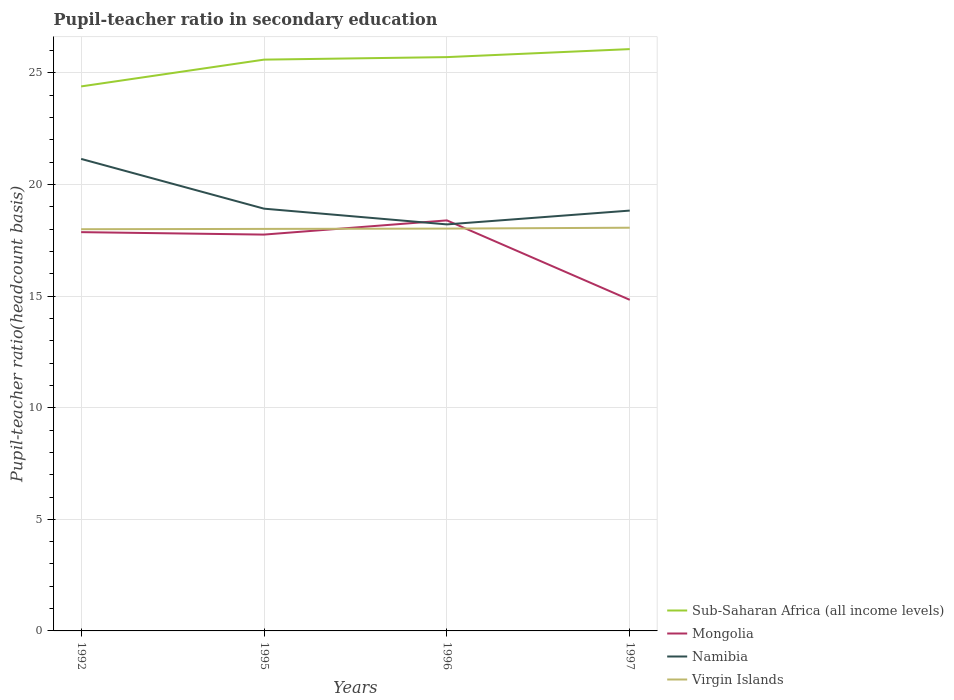How many different coloured lines are there?
Your answer should be very brief. 4. Does the line corresponding to Sub-Saharan Africa (all income levels) intersect with the line corresponding to Namibia?
Offer a very short reply. No. Is the number of lines equal to the number of legend labels?
Give a very brief answer. Yes. Across all years, what is the maximum pupil-teacher ratio in secondary education in Namibia?
Your response must be concise. 18.22. In which year was the pupil-teacher ratio in secondary education in Mongolia maximum?
Offer a very short reply. 1997. What is the total pupil-teacher ratio in secondary education in Sub-Saharan Africa (all income levels) in the graph?
Offer a very short reply. -0.47. What is the difference between the highest and the second highest pupil-teacher ratio in secondary education in Sub-Saharan Africa (all income levels)?
Your answer should be compact. 1.67. How many years are there in the graph?
Give a very brief answer. 4. What is the difference between two consecutive major ticks on the Y-axis?
Provide a short and direct response. 5. Are the values on the major ticks of Y-axis written in scientific E-notation?
Provide a short and direct response. No. Does the graph contain grids?
Ensure brevity in your answer.  Yes. How many legend labels are there?
Offer a very short reply. 4. How are the legend labels stacked?
Your response must be concise. Vertical. What is the title of the graph?
Give a very brief answer. Pupil-teacher ratio in secondary education. Does "Hong Kong" appear as one of the legend labels in the graph?
Keep it short and to the point. No. What is the label or title of the X-axis?
Offer a very short reply. Years. What is the label or title of the Y-axis?
Give a very brief answer. Pupil-teacher ratio(headcount basis). What is the Pupil-teacher ratio(headcount basis) of Sub-Saharan Africa (all income levels) in 1992?
Your response must be concise. 24.4. What is the Pupil-teacher ratio(headcount basis) of Mongolia in 1992?
Make the answer very short. 17.87. What is the Pupil-teacher ratio(headcount basis) in Namibia in 1992?
Provide a short and direct response. 21.15. What is the Pupil-teacher ratio(headcount basis) of Sub-Saharan Africa (all income levels) in 1995?
Provide a succinct answer. 25.6. What is the Pupil-teacher ratio(headcount basis) of Mongolia in 1995?
Offer a terse response. 17.76. What is the Pupil-teacher ratio(headcount basis) in Namibia in 1995?
Keep it short and to the point. 18.92. What is the Pupil-teacher ratio(headcount basis) in Virgin Islands in 1995?
Provide a short and direct response. 18.01. What is the Pupil-teacher ratio(headcount basis) of Sub-Saharan Africa (all income levels) in 1996?
Give a very brief answer. 25.71. What is the Pupil-teacher ratio(headcount basis) in Mongolia in 1996?
Offer a terse response. 18.4. What is the Pupil-teacher ratio(headcount basis) of Namibia in 1996?
Offer a terse response. 18.22. What is the Pupil-teacher ratio(headcount basis) in Virgin Islands in 1996?
Make the answer very short. 18.03. What is the Pupil-teacher ratio(headcount basis) in Sub-Saharan Africa (all income levels) in 1997?
Give a very brief answer. 26.07. What is the Pupil-teacher ratio(headcount basis) of Mongolia in 1997?
Provide a succinct answer. 14.84. What is the Pupil-teacher ratio(headcount basis) of Namibia in 1997?
Your answer should be very brief. 18.83. What is the Pupil-teacher ratio(headcount basis) in Virgin Islands in 1997?
Ensure brevity in your answer.  18.07. Across all years, what is the maximum Pupil-teacher ratio(headcount basis) of Sub-Saharan Africa (all income levels)?
Offer a very short reply. 26.07. Across all years, what is the maximum Pupil-teacher ratio(headcount basis) of Mongolia?
Your answer should be compact. 18.4. Across all years, what is the maximum Pupil-teacher ratio(headcount basis) of Namibia?
Provide a short and direct response. 21.15. Across all years, what is the maximum Pupil-teacher ratio(headcount basis) in Virgin Islands?
Give a very brief answer. 18.07. Across all years, what is the minimum Pupil-teacher ratio(headcount basis) in Sub-Saharan Africa (all income levels)?
Your response must be concise. 24.4. Across all years, what is the minimum Pupil-teacher ratio(headcount basis) in Mongolia?
Provide a succinct answer. 14.84. Across all years, what is the minimum Pupil-teacher ratio(headcount basis) of Namibia?
Your answer should be very brief. 18.22. Across all years, what is the minimum Pupil-teacher ratio(headcount basis) in Virgin Islands?
Your answer should be compact. 18. What is the total Pupil-teacher ratio(headcount basis) of Sub-Saharan Africa (all income levels) in the graph?
Offer a terse response. 101.78. What is the total Pupil-teacher ratio(headcount basis) in Mongolia in the graph?
Provide a short and direct response. 68.86. What is the total Pupil-teacher ratio(headcount basis) of Namibia in the graph?
Your response must be concise. 77.12. What is the total Pupil-teacher ratio(headcount basis) of Virgin Islands in the graph?
Offer a very short reply. 72.11. What is the difference between the Pupil-teacher ratio(headcount basis) of Sub-Saharan Africa (all income levels) in 1992 and that in 1995?
Give a very brief answer. -1.2. What is the difference between the Pupil-teacher ratio(headcount basis) in Mongolia in 1992 and that in 1995?
Provide a succinct answer. 0.11. What is the difference between the Pupil-teacher ratio(headcount basis) in Namibia in 1992 and that in 1995?
Your answer should be very brief. 2.23. What is the difference between the Pupil-teacher ratio(headcount basis) of Virgin Islands in 1992 and that in 1995?
Your answer should be compact. -0.01. What is the difference between the Pupil-teacher ratio(headcount basis) in Sub-Saharan Africa (all income levels) in 1992 and that in 1996?
Make the answer very short. -1.31. What is the difference between the Pupil-teacher ratio(headcount basis) of Mongolia in 1992 and that in 1996?
Provide a succinct answer. -0.53. What is the difference between the Pupil-teacher ratio(headcount basis) of Namibia in 1992 and that in 1996?
Give a very brief answer. 2.93. What is the difference between the Pupil-teacher ratio(headcount basis) of Virgin Islands in 1992 and that in 1996?
Provide a short and direct response. -0.03. What is the difference between the Pupil-teacher ratio(headcount basis) in Sub-Saharan Africa (all income levels) in 1992 and that in 1997?
Provide a short and direct response. -1.67. What is the difference between the Pupil-teacher ratio(headcount basis) of Mongolia in 1992 and that in 1997?
Your response must be concise. 3.03. What is the difference between the Pupil-teacher ratio(headcount basis) in Namibia in 1992 and that in 1997?
Provide a short and direct response. 2.32. What is the difference between the Pupil-teacher ratio(headcount basis) in Virgin Islands in 1992 and that in 1997?
Give a very brief answer. -0.07. What is the difference between the Pupil-teacher ratio(headcount basis) in Sub-Saharan Africa (all income levels) in 1995 and that in 1996?
Provide a short and direct response. -0.11. What is the difference between the Pupil-teacher ratio(headcount basis) of Mongolia in 1995 and that in 1996?
Offer a very short reply. -0.64. What is the difference between the Pupil-teacher ratio(headcount basis) of Namibia in 1995 and that in 1996?
Offer a terse response. 0.71. What is the difference between the Pupil-teacher ratio(headcount basis) of Virgin Islands in 1995 and that in 1996?
Give a very brief answer. -0.01. What is the difference between the Pupil-teacher ratio(headcount basis) in Sub-Saharan Africa (all income levels) in 1995 and that in 1997?
Your answer should be compact. -0.47. What is the difference between the Pupil-teacher ratio(headcount basis) in Mongolia in 1995 and that in 1997?
Offer a very short reply. 2.92. What is the difference between the Pupil-teacher ratio(headcount basis) in Namibia in 1995 and that in 1997?
Keep it short and to the point. 0.09. What is the difference between the Pupil-teacher ratio(headcount basis) in Virgin Islands in 1995 and that in 1997?
Offer a very short reply. -0.05. What is the difference between the Pupil-teacher ratio(headcount basis) in Sub-Saharan Africa (all income levels) in 1996 and that in 1997?
Offer a terse response. -0.36. What is the difference between the Pupil-teacher ratio(headcount basis) of Mongolia in 1996 and that in 1997?
Offer a terse response. 3.56. What is the difference between the Pupil-teacher ratio(headcount basis) in Namibia in 1996 and that in 1997?
Ensure brevity in your answer.  -0.62. What is the difference between the Pupil-teacher ratio(headcount basis) in Virgin Islands in 1996 and that in 1997?
Give a very brief answer. -0.04. What is the difference between the Pupil-teacher ratio(headcount basis) in Sub-Saharan Africa (all income levels) in 1992 and the Pupil-teacher ratio(headcount basis) in Mongolia in 1995?
Provide a short and direct response. 6.64. What is the difference between the Pupil-teacher ratio(headcount basis) of Sub-Saharan Africa (all income levels) in 1992 and the Pupil-teacher ratio(headcount basis) of Namibia in 1995?
Your answer should be compact. 5.48. What is the difference between the Pupil-teacher ratio(headcount basis) in Sub-Saharan Africa (all income levels) in 1992 and the Pupil-teacher ratio(headcount basis) in Virgin Islands in 1995?
Provide a short and direct response. 6.38. What is the difference between the Pupil-teacher ratio(headcount basis) in Mongolia in 1992 and the Pupil-teacher ratio(headcount basis) in Namibia in 1995?
Keep it short and to the point. -1.05. What is the difference between the Pupil-teacher ratio(headcount basis) in Mongolia in 1992 and the Pupil-teacher ratio(headcount basis) in Virgin Islands in 1995?
Your answer should be compact. -0.14. What is the difference between the Pupil-teacher ratio(headcount basis) in Namibia in 1992 and the Pupil-teacher ratio(headcount basis) in Virgin Islands in 1995?
Your answer should be very brief. 3.14. What is the difference between the Pupil-teacher ratio(headcount basis) of Sub-Saharan Africa (all income levels) in 1992 and the Pupil-teacher ratio(headcount basis) of Mongolia in 1996?
Offer a terse response. 6. What is the difference between the Pupil-teacher ratio(headcount basis) in Sub-Saharan Africa (all income levels) in 1992 and the Pupil-teacher ratio(headcount basis) in Namibia in 1996?
Keep it short and to the point. 6.18. What is the difference between the Pupil-teacher ratio(headcount basis) in Sub-Saharan Africa (all income levels) in 1992 and the Pupil-teacher ratio(headcount basis) in Virgin Islands in 1996?
Offer a terse response. 6.37. What is the difference between the Pupil-teacher ratio(headcount basis) of Mongolia in 1992 and the Pupil-teacher ratio(headcount basis) of Namibia in 1996?
Offer a very short reply. -0.35. What is the difference between the Pupil-teacher ratio(headcount basis) of Mongolia in 1992 and the Pupil-teacher ratio(headcount basis) of Virgin Islands in 1996?
Your answer should be very brief. -0.16. What is the difference between the Pupil-teacher ratio(headcount basis) of Namibia in 1992 and the Pupil-teacher ratio(headcount basis) of Virgin Islands in 1996?
Give a very brief answer. 3.12. What is the difference between the Pupil-teacher ratio(headcount basis) of Sub-Saharan Africa (all income levels) in 1992 and the Pupil-teacher ratio(headcount basis) of Mongolia in 1997?
Make the answer very short. 9.56. What is the difference between the Pupil-teacher ratio(headcount basis) of Sub-Saharan Africa (all income levels) in 1992 and the Pupil-teacher ratio(headcount basis) of Namibia in 1997?
Your answer should be compact. 5.56. What is the difference between the Pupil-teacher ratio(headcount basis) in Sub-Saharan Africa (all income levels) in 1992 and the Pupil-teacher ratio(headcount basis) in Virgin Islands in 1997?
Offer a terse response. 6.33. What is the difference between the Pupil-teacher ratio(headcount basis) of Mongolia in 1992 and the Pupil-teacher ratio(headcount basis) of Namibia in 1997?
Offer a very short reply. -0.97. What is the difference between the Pupil-teacher ratio(headcount basis) of Mongolia in 1992 and the Pupil-teacher ratio(headcount basis) of Virgin Islands in 1997?
Ensure brevity in your answer.  -0.2. What is the difference between the Pupil-teacher ratio(headcount basis) in Namibia in 1992 and the Pupil-teacher ratio(headcount basis) in Virgin Islands in 1997?
Ensure brevity in your answer.  3.08. What is the difference between the Pupil-teacher ratio(headcount basis) in Sub-Saharan Africa (all income levels) in 1995 and the Pupil-teacher ratio(headcount basis) in Mongolia in 1996?
Your answer should be very brief. 7.2. What is the difference between the Pupil-teacher ratio(headcount basis) of Sub-Saharan Africa (all income levels) in 1995 and the Pupil-teacher ratio(headcount basis) of Namibia in 1996?
Offer a terse response. 7.38. What is the difference between the Pupil-teacher ratio(headcount basis) in Sub-Saharan Africa (all income levels) in 1995 and the Pupil-teacher ratio(headcount basis) in Virgin Islands in 1996?
Make the answer very short. 7.57. What is the difference between the Pupil-teacher ratio(headcount basis) of Mongolia in 1995 and the Pupil-teacher ratio(headcount basis) of Namibia in 1996?
Give a very brief answer. -0.46. What is the difference between the Pupil-teacher ratio(headcount basis) of Mongolia in 1995 and the Pupil-teacher ratio(headcount basis) of Virgin Islands in 1996?
Give a very brief answer. -0.27. What is the difference between the Pupil-teacher ratio(headcount basis) of Namibia in 1995 and the Pupil-teacher ratio(headcount basis) of Virgin Islands in 1996?
Your answer should be very brief. 0.89. What is the difference between the Pupil-teacher ratio(headcount basis) of Sub-Saharan Africa (all income levels) in 1995 and the Pupil-teacher ratio(headcount basis) of Mongolia in 1997?
Offer a terse response. 10.76. What is the difference between the Pupil-teacher ratio(headcount basis) in Sub-Saharan Africa (all income levels) in 1995 and the Pupil-teacher ratio(headcount basis) in Namibia in 1997?
Provide a short and direct response. 6.76. What is the difference between the Pupil-teacher ratio(headcount basis) of Sub-Saharan Africa (all income levels) in 1995 and the Pupil-teacher ratio(headcount basis) of Virgin Islands in 1997?
Provide a short and direct response. 7.53. What is the difference between the Pupil-teacher ratio(headcount basis) in Mongolia in 1995 and the Pupil-teacher ratio(headcount basis) in Namibia in 1997?
Offer a terse response. -1.08. What is the difference between the Pupil-teacher ratio(headcount basis) in Mongolia in 1995 and the Pupil-teacher ratio(headcount basis) in Virgin Islands in 1997?
Give a very brief answer. -0.31. What is the difference between the Pupil-teacher ratio(headcount basis) in Namibia in 1995 and the Pupil-teacher ratio(headcount basis) in Virgin Islands in 1997?
Offer a terse response. 0.85. What is the difference between the Pupil-teacher ratio(headcount basis) of Sub-Saharan Africa (all income levels) in 1996 and the Pupil-teacher ratio(headcount basis) of Mongolia in 1997?
Your answer should be very brief. 10.88. What is the difference between the Pupil-teacher ratio(headcount basis) in Sub-Saharan Africa (all income levels) in 1996 and the Pupil-teacher ratio(headcount basis) in Namibia in 1997?
Your answer should be compact. 6.88. What is the difference between the Pupil-teacher ratio(headcount basis) of Sub-Saharan Africa (all income levels) in 1996 and the Pupil-teacher ratio(headcount basis) of Virgin Islands in 1997?
Your response must be concise. 7.64. What is the difference between the Pupil-teacher ratio(headcount basis) of Mongolia in 1996 and the Pupil-teacher ratio(headcount basis) of Namibia in 1997?
Make the answer very short. -0.44. What is the difference between the Pupil-teacher ratio(headcount basis) of Mongolia in 1996 and the Pupil-teacher ratio(headcount basis) of Virgin Islands in 1997?
Your response must be concise. 0.33. What is the difference between the Pupil-teacher ratio(headcount basis) of Namibia in 1996 and the Pupil-teacher ratio(headcount basis) of Virgin Islands in 1997?
Give a very brief answer. 0.15. What is the average Pupil-teacher ratio(headcount basis) of Sub-Saharan Africa (all income levels) per year?
Provide a short and direct response. 25.45. What is the average Pupil-teacher ratio(headcount basis) of Mongolia per year?
Offer a terse response. 17.22. What is the average Pupil-teacher ratio(headcount basis) in Namibia per year?
Provide a short and direct response. 19.28. What is the average Pupil-teacher ratio(headcount basis) of Virgin Islands per year?
Make the answer very short. 18.03. In the year 1992, what is the difference between the Pupil-teacher ratio(headcount basis) in Sub-Saharan Africa (all income levels) and Pupil-teacher ratio(headcount basis) in Mongolia?
Keep it short and to the point. 6.53. In the year 1992, what is the difference between the Pupil-teacher ratio(headcount basis) in Sub-Saharan Africa (all income levels) and Pupil-teacher ratio(headcount basis) in Namibia?
Offer a terse response. 3.25. In the year 1992, what is the difference between the Pupil-teacher ratio(headcount basis) of Sub-Saharan Africa (all income levels) and Pupil-teacher ratio(headcount basis) of Virgin Islands?
Your answer should be very brief. 6.4. In the year 1992, what is the difference between the Pupil-teacher ratio(headcount basis) of Mongolia and Pupil-teacher ratio(headcount basis) of Namibia?
Your response must be concise. -3.28. In the year 1992, what is the difference between the Pupil-teacher ratio(headcount basis) in Mongolia and Pupil-teacher ratio(headcount basis) in Virgin Islands?
Your response must be concise. -0.13. In the year 1992, what is the difference between the Pupil-teacher ratio(headcount basis) of Namibia and Pupil-teacher ratio(headcount basis) of Virgin Islands?
Offer a terse response. 3.15. In the year 1995, what is the difference between the Pupil-teacher ratio(headcount basis) of Sub-Saharan Africa (all income levels) and Pupil-teacher ratio(headcount basis) of Mongolia?
Offer a terse response. 7.84. In the year 1995, what is the difference between the Pupil-teacher ratio(headcount basis) in Sub-Saharan Africa (all income levels) and Pupil-teacher ratio(headcount basis) in Namibia?
Offer a terse response. 6.68. In the year 1995, what is the difference between the Pupil-teacher ratio(headcount basis) of Sub-Saharan Africa (all income levels) and Pupil-teacher ratio(headcount basis) of Virgin Islands?
Offer a terse response. 7.58. In the year 1995, what is the difference between the Pupil-teacher ratio(headcount basis) of Mongolia and Pupil-teacher ratio(headcount basis) of Namibia?
Your answer should be very brief. -1.16. In the year 1995, what is the difference between the Pupil-teacher ratio(headcount basis) in Mongolia and Pupil-teacher ratio(headcount basis) in Virgin Islands?
Provide a short and direct response. -0.25. In the year 1995, what is the difference between the Pupil-teacher ratio(headcount basis) of Namibia and Pupil-teacher ratio(headcount basis) of Virgin Islands?
Offer a terse response. 0.91. In the year 1996, what is the difference between the Pupil-teacher ratio(headcount basis) in Sub-Saharan Africa (all income levels) and Pupil-teacher ratio(headcount basis) in Mongolia?
Your response must be concise. 7.32. In the year 1996, what is the difference between the Pupil-teacher ratio(headcount basis) of Sub-Saharan Africa (all income levels) and Pupil-teacher ratio(headcount basis) of Namibia?
Give a very brief answer. 7.5. In the year 1996, what is the difference between the Pupil-teacher ratio(headcount basis) of Sub-Saharan Africa (all income levels) and Pupil-teacher ratio(headcount basis) of Virgin Islands?
Offer a very short reply. 7.68. In the year 1996, what is the difference between the Pupil-teacher ratio(headcount basis) of Mongolia and Pupil-teacher ratio(headcount basis) of Namibia?
Your answer should be very brief. 0.18. In the year 1996, what is the difference between the Pupil-teacher ratio(headcount basis) in Mongolia and Pupil-teacher ratio(headcount basis) in Virgin Islands?
Offer a terse response. 0.37. In the year 1996, what is the difference between the Pupil-teacher ratio(headcount basis) in Namibia and Pupil-teacher ratio(headcount basis) in Virgin Islands?
Offer a very short reply. 0.19. In the year 1997, what is the difference between the Pupil-teacher ratio(headcount basis) of Sub-Saharan Africa (all income levels) and Pupil-teacher ratio(headcount basis) of Mongolia?
Offer a very short reply. 11.23. In the year 1997, what is the difference between the Pupil-teacher ratio(headcount basis) of Sub-Saharan Africa (all income levels) and Pupil-teacher ratio(headcount basis) of Namibia?
Keep it short and to the point. 7.24. In the year 1997, what is the difference between the Pupil-teacher ratio(headcount basis) of Sub-Saharan Africa (all income levels) and Pupil-teacher ratio(headcount basis) of Virgin Islands?
Provide a succinct answer. 8. In the year 1997, what is the difference between the Pupil-teacher ratio(headcount basis) of Mongolia and Pupil-teacher ratio(headcount basis) of Namibia?
Provide a short and direct response. -4. In the year 1997, what is the difference between the Pupil-teacher ratio(headcount basis) of Mongolia and Pupil-teacher ratio(headcount basis) of Virgin Islands?
Keep it short and to the point. -3.23. In the year 1997, what is the difference between the Pupil-teacher ratio(headcount basis) in Namibia and Pupil-teacher ratio(headcount basis) in Virgin Islands?
Your answer should be compact. 0.77. What is the ratio of the Pupil-teacher ratio(headcount basis) of Sub-Saharan Africa (all income levels) in 1992 to that in 1995?
Provide a succinct answer. 0.95. What is the ratio of the Pupil-teacher ratio(headcount basis) of Namibia in 1992 to that in 1995?
Offer a very short reply. 1.12. What is the ratio of the Pupil-teacher ratio(headcount basis) of Sub-Saharan Africa (all income levels) in 1992 to that in 1996?
Ensure brevity in your answer.  0.95. What is the ratio of the Pupil-teacher ratio(headcount basis) in Mongolia in 1992 to that in 1996?
Offer a terse response. 0.97. What is the ratio of the Pupil-teacher ratio(headcount basis) in Namibia in 1992 to that in 1996?
Offer a very short reply. 1.16. What is the ratio of the Pupil-teacher ratio(headcount basis) in Sub-Saharan Africa (all income levels) in 1992 to that in 1997?
Your answer should be very brief. 0.94. What is the ratio of the Pupil-teacher ratio(headcount basis) in Mongolia in 1992 to that in 1997?
Your answer should be compact. 1.2. What is the ratio of the Pupil-teacher ratio(headcount basis) in Namibia in 1992 to that in 1997?
Offer a terse response. 1.12. What is the ratio of the Pupil-teacher ratio(headcount basis) of Mongolia in 1995 to that in 1996?
Provide a short and direct response. 0.97. What is the ratio of the Pupil-teacher ratio(headcount basis) in Namibia in 1995 to that in 1996?
Ensure brevity in your answer.  1.04. What is the ratio of the Pupil-teacher ratio(headcount basis) in Sub-Saharan Africa (all income levels) in 1995 to that in 1997?
Your answer should be compact. 0.98. What is the ratio of the Pupil-teacher ratio(headcount basis) in Mongolia in 1995 to that in 1997?
Keep it short and to the point. 1.2. What is the ratio of the Pupil-teacher ratio(headcount basis) in Namibia in 1995 to that in 1997?
Offer a terse response. 1. What is the ratio of the Pupil-teacher ratio(headcount basis) of Virgin Islands in 1995 to that in 1997?
Give a very brief answer. 1. What is the ratio of the Pupil-teacher ratio(headcount basis) in Sub-Saharan Africa (all income levels) in 1996 to that in 1997?
Offer a terse response. 0.99. What is the ratio of the Pupil-teacher ratio(headcount basis) of Mongolia in 1996 to that in 1997?
Make the answer very short. 1.24. What is the ratio of the Pupil-teacher ratio(headcount basis) in Namibia in 1996 to that in 1997?
Ensure brevity in your answer.  0.97. What is the ratio of the Pupil-teacher ratio(headcount basis) of Virgin Islands in 1996 to that in 1997?
Make the answer very short. 1. What is the difference between the highest and the second highest Pupil-teacher ratio(headcount basis) of Sub-Saharan Africa (all income levels)?
Provide a short and direct response. 0.36. What is the difference between the highest and the second highest Pupil-teacher ratio(headcount basis) of Mongolia?
Your answer should be compact. 0.53. What is the difference between the highest and the second highest Pupil-teacher ratio(headcount basis) in Namibia?
Offer a very short reply. 2.23. What is the difference between the highest and the second highest Pupil-teacher ratio(headcount basis) in Virgin Islands?
Offer a terse response. 0.04. What is the difference between the highest and the lowest Pupil-teacher ratio(headcount basis) in Sub-Saharan Africa (all income levels)?
Your answer should be very brief. 1.67. What is the difference between the highest and the lowest Pupil-teacher ratio(headcount basis) of Mongolia?
Your response must be concise. 3.56. What is the difference between the highest and the lowest Pupil-teacher ratio(headcount basis) in Namibia?
Your answer should be compact. 2.93. What is the difference between the highest and the lowest Pupil-teacher ratio(headcount basis) of Virgin Islands?
Offer a very short reply. 0.07. 